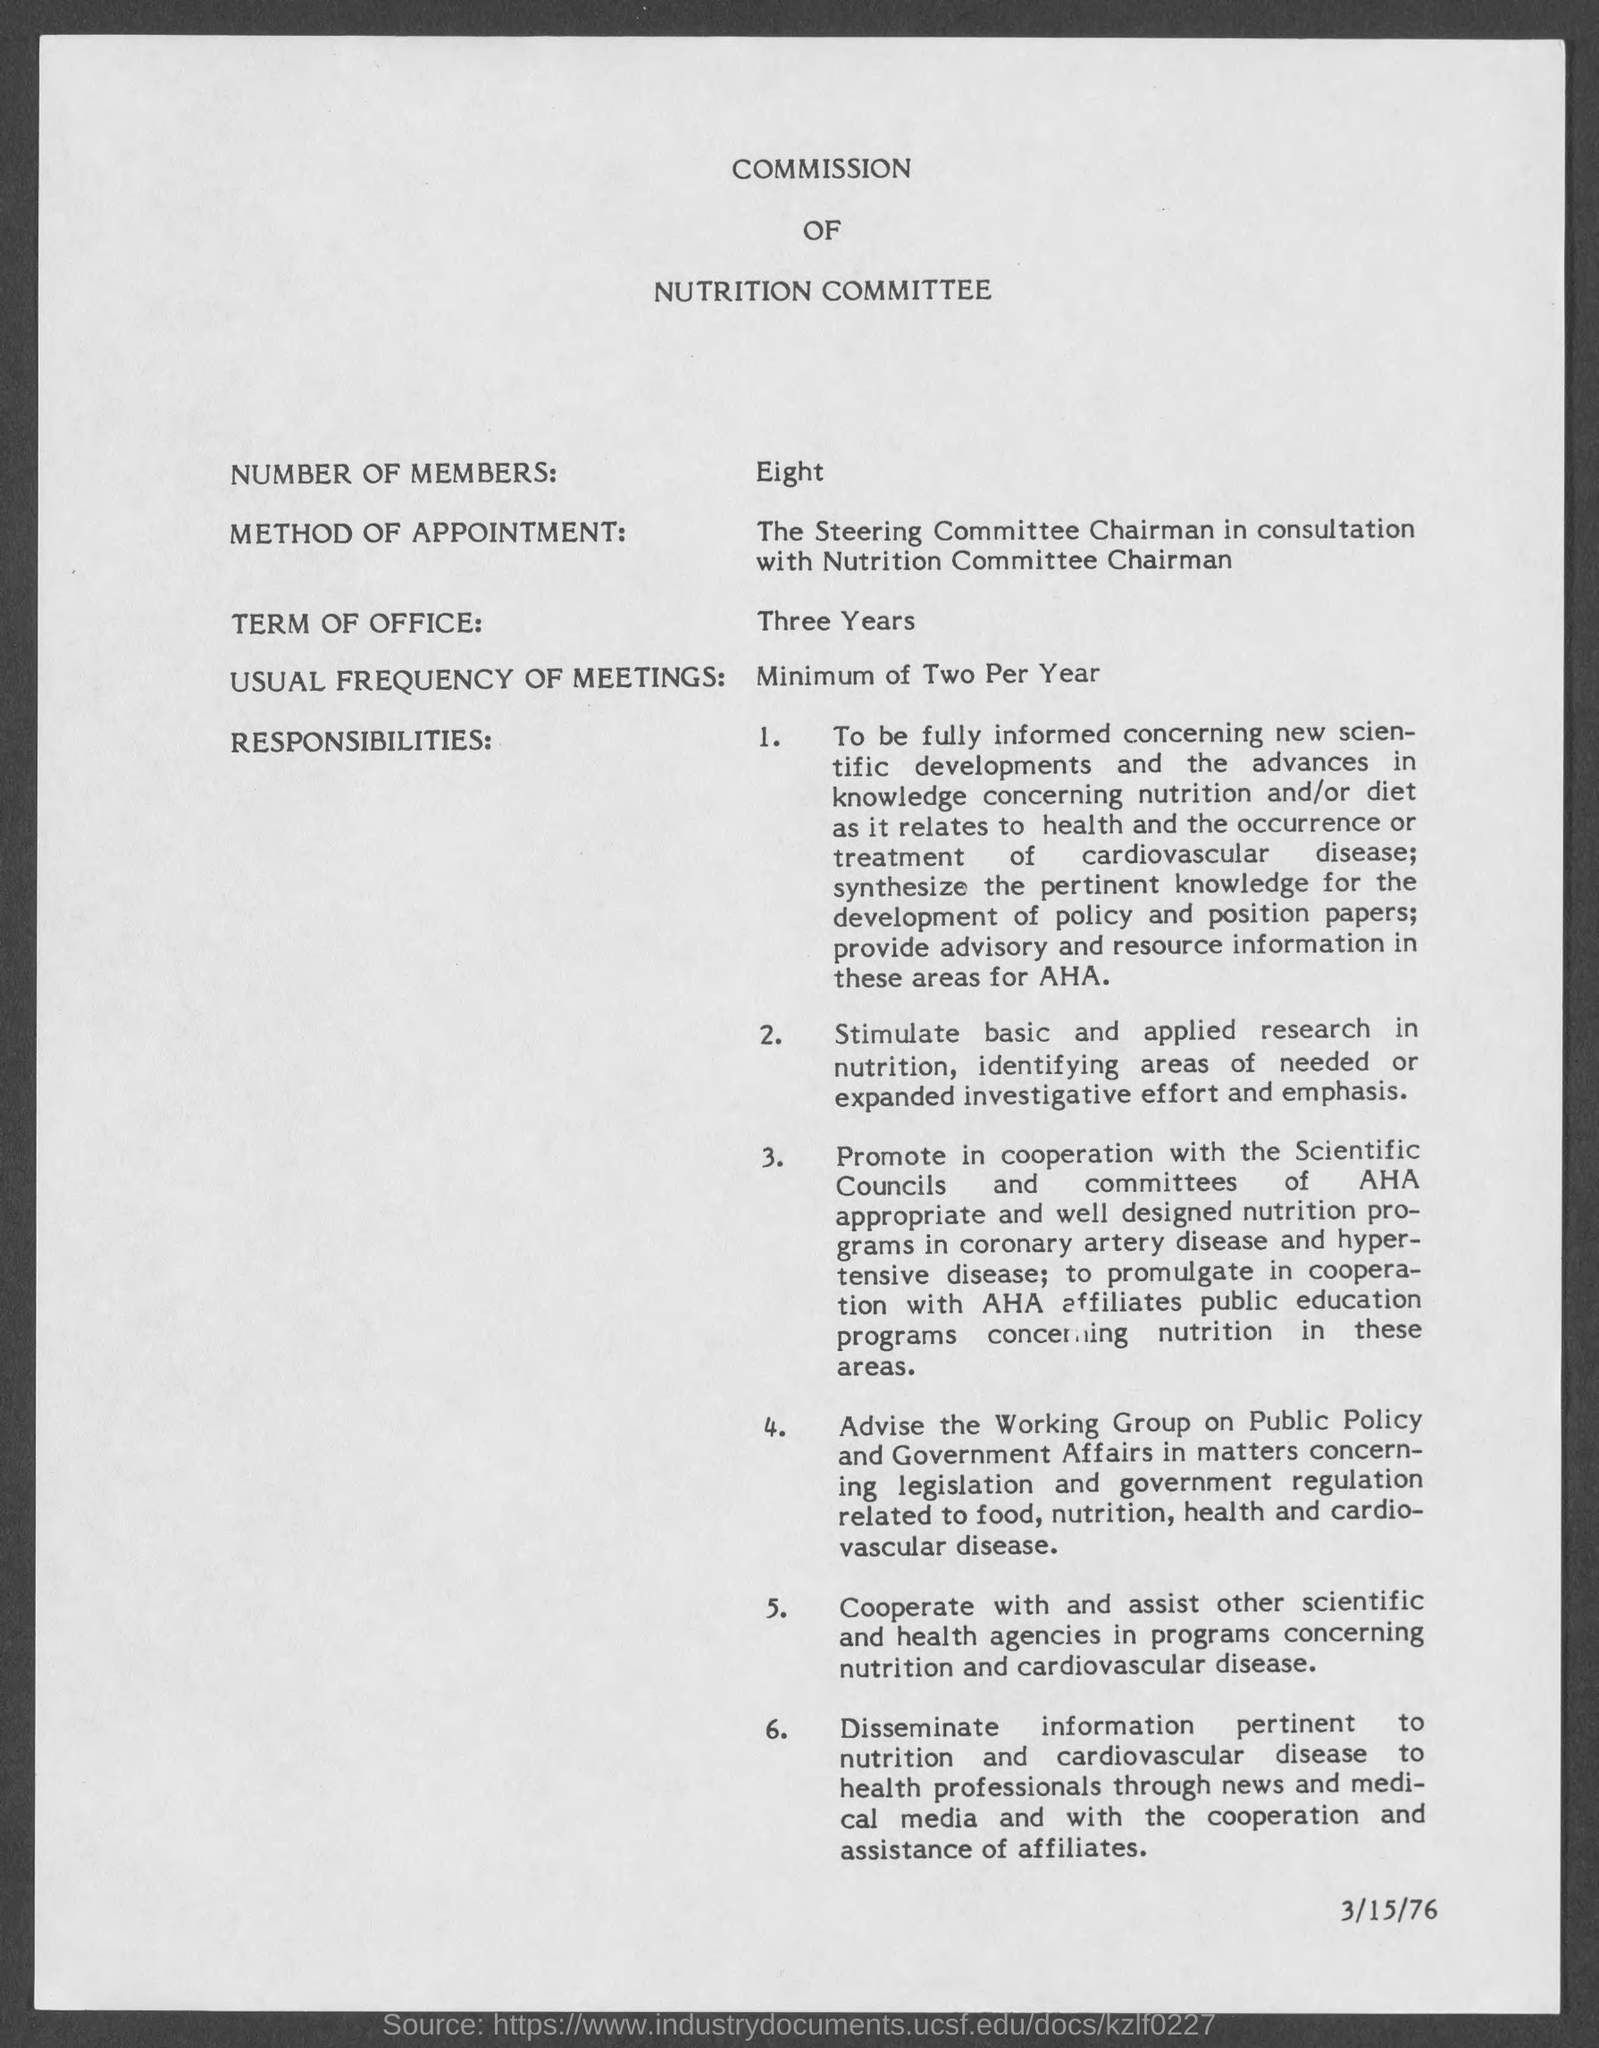Outline some significant characteristics in this image. The usual frequency of meetings is at least two per year. The number of members is eight. The title of the document is "Commission of Nutrition Committee. The term of office is three years. 